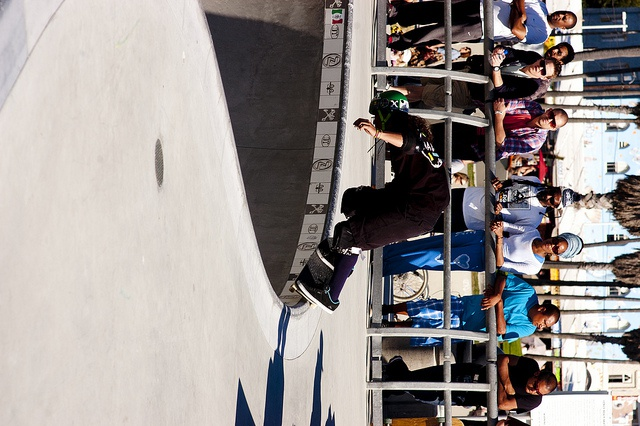Describe the objects in this image and their specific colors. I can see people in gray, black, white, and maroon tones, people in gray, black, white, and navy tones, people in gray, black, white, and blue tones, people in gray, black, navy, lightblue, and blue tones, and people in gray, black, maroon, brown, and salmon tones in this image. 